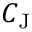<formula> <loc_0><loc_0><loc_500><loc_500>C _ { J }</formula> 